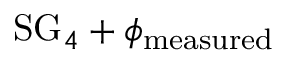<formula> <loc_0><loc_0><loc_500><loc_500>S G _ { 4 } + \phi _ { m e a s u r e d }</formula> 